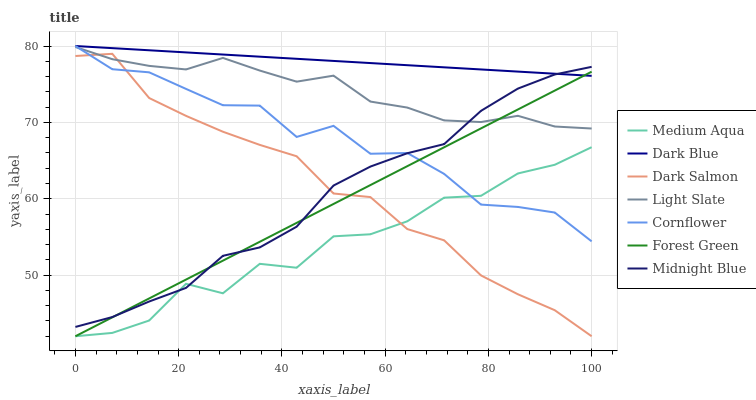Does Medium Aqua have the minimum area under the curve?
Answer yes or no. Yes. Does Dark Blue have the maximum area under the curve?
Answer yes or no. Yes. Does Midnight Blue have the minimum area under the curve?
Answer yes or no. No. Does Midnight Blue have the maximum area under the curve?
Answer yes or no. No. Is Dark Blue the smoothest?
Answer yes or no. Yes. Is Medium Aqua the roughest?
Answer yes or no. Yes. Is Midnight Blue the smoothest?
Answer yes or no. No. Is Midnight Blue the roughest?
Answer yes or no. No. Does Midnight Blue have the lowest value?
Answer yes or no. No. Does Dark Blue have the highest value?
Answer yes or no. Yes. Does Midnight Blue have the highest value?
Answer yes or no. No. Is Medium Aqua less than Dark Blue?
Answer yes or no. Yes. Is Light Slate greater than Medium Aqua?
Answer yes or no. Yes. Does Medium Aqua intersect Dark Blue?
Answer yes or no. No. 